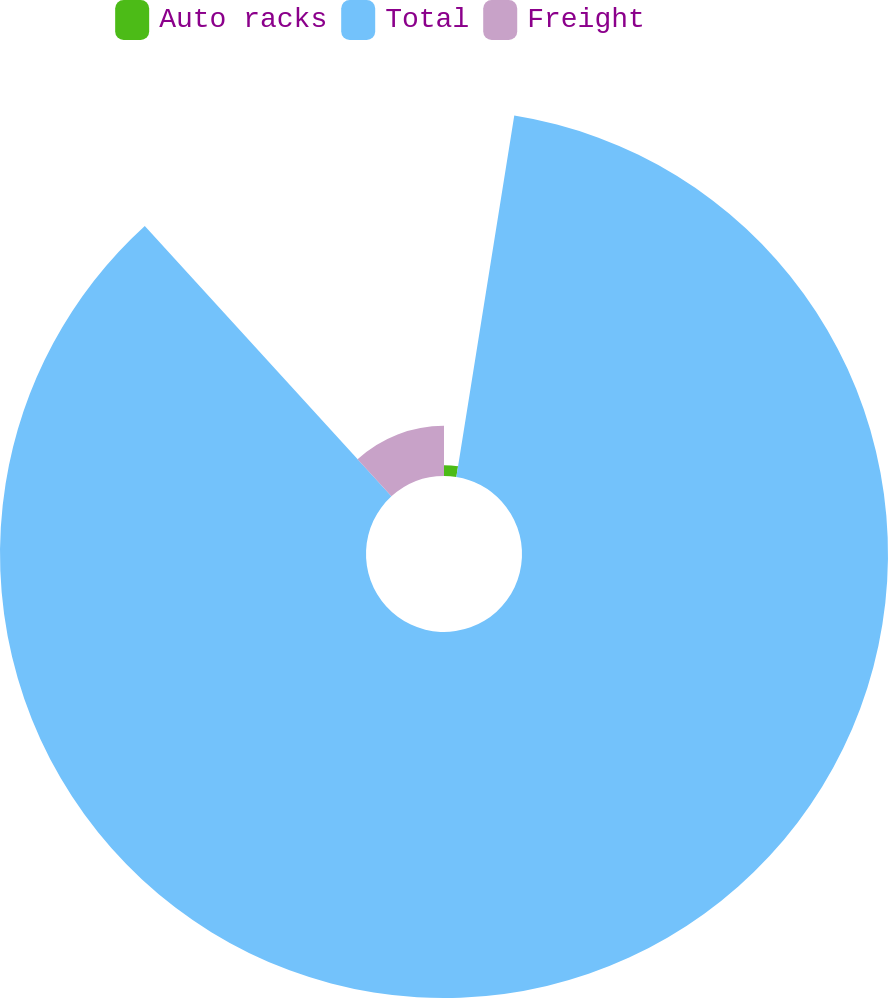Convert chart to OTSL. <chart><loc_0><loc_0><loc_500><loc_500><pie_chart><fcel>Auto racks<fcel>Total<fcel>Freight<nl><fcel>2.53%<fcel>85.71%<fcel>11.77%<nl></chart> 